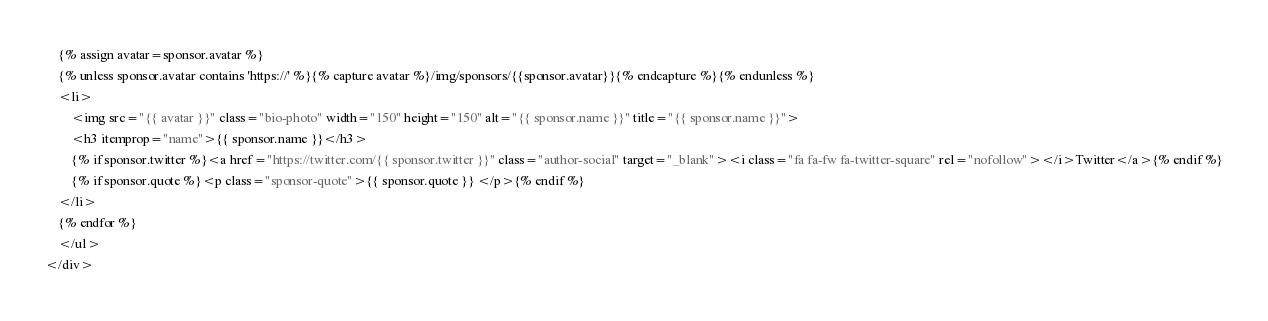<code> <loc_0><loc_0><loc_500><loc_500><_HTML_>	{% assign avatar=sponsor.avatar %}
	{% unless sponsor.avatar contains 'https://' %}{% capture avatar %}/img/sponsors/{{sponsor.avatar}}{% endcapture %}{% endunless %}
	<li>
		<img src="{{ avatar }}" class="bio-photo" width="150" height="150" alt="{{ sponsor.name }}" title="{{ sponsor.name }}">
	    <h3 itemprop="name">{{ sponsor.name }}</h3>
	    {% if sponsor.twitter %}<a href="https://twitter.com/{{ sponsor.twitter }}" class="author-social" target="_blank"><i class="fa fa-fw fa-twitter-square" rel="nofollow"></i>Twitter</a>{% endif %}
	    {% if sponsor.quote %}<p class="sponsor-quote">{{ sponsor.quote }} </p>{% endif %}
	</li>
	{% endfor %}
	</ul>
</div>
</code> 